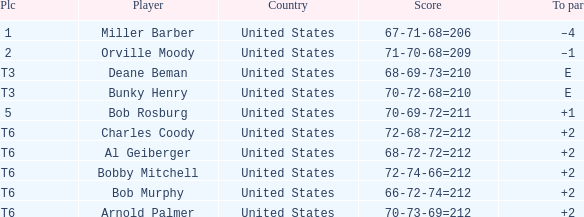What is the to par of player bunky henry? E. 